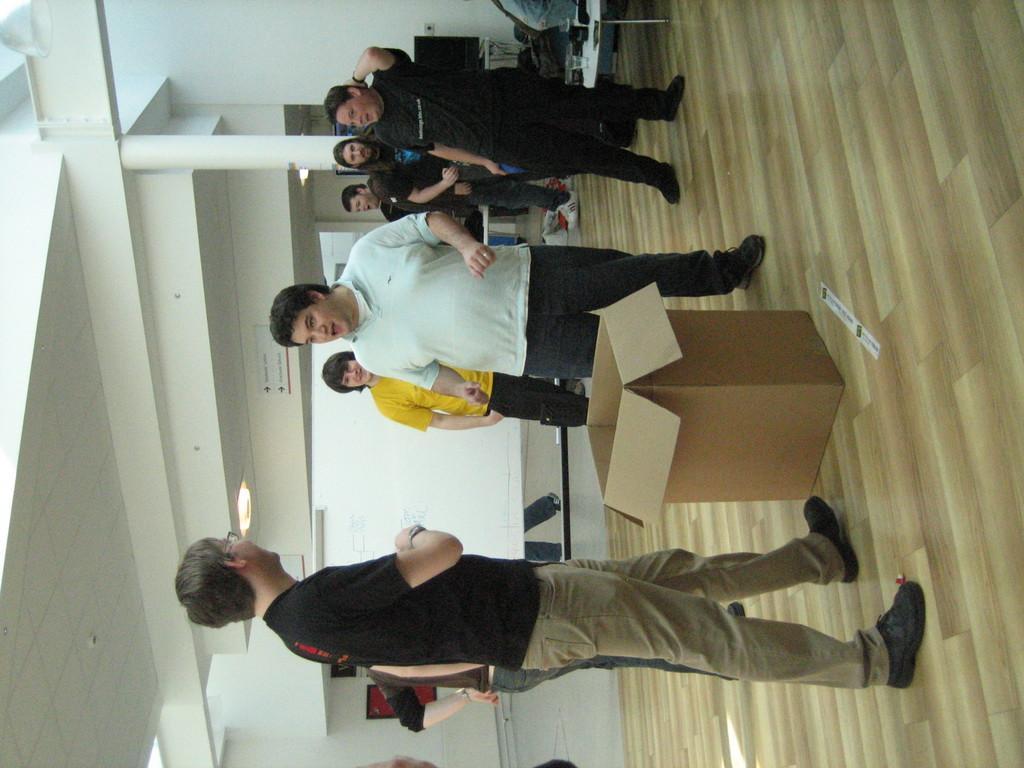Describe this image in one or two sentences. In this picture we can see a group of people standing on the path and in front of the people there is a cardboard box. Behind the people there is a table with a glass and other things. Behind the people there is a wall and a pillar and there are ceiling lights on the top. 